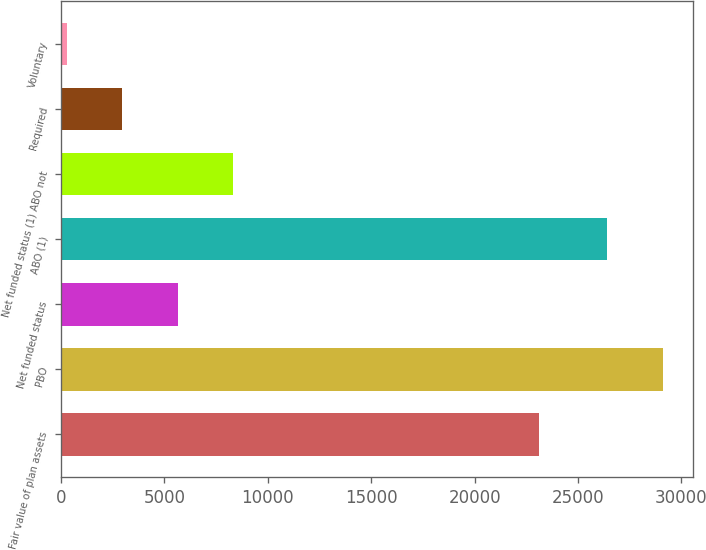<chart> <loc_0><loc_0><loc_500><loc_500><bar_chart><fcel>Fair value of plan assets<fcel>PBO<fcel>Net funded status<fcel>ABO (1)<fcel>Net funded status (1) ABO not<fcel>Required<fcel>Voluntary<nl><fcel>23099<fcel>29099<fcel>5644<fcel>26413<fcel>8330<fcel>2958<fcel>272<nl></chart> 